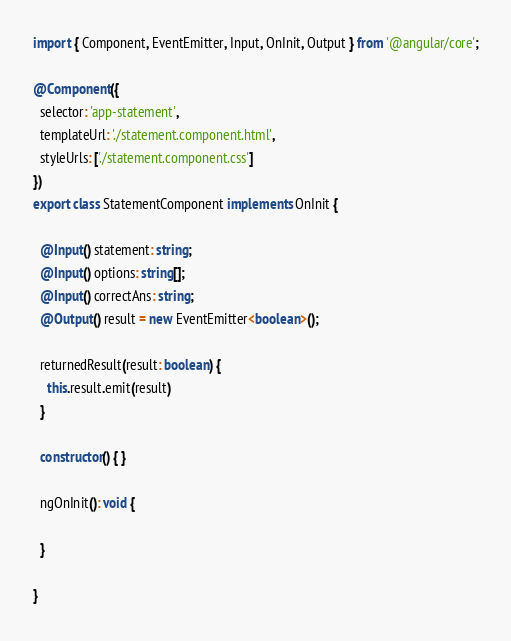Convert code to text. <code><loc_0><loc_0><loc_500><loc_500><_TypeScript_>import { Component, EventEmitter, Input, OnInit, Output } from '@angular/core';

@Component({
  selector: 'app-statement',
  templateUrl: './statement.component.html',
  styleUrls: ['./statement.component.css']
})
export class StatementComponent implements OnInit {

  @Input() statement: string;
  @Input() options: string[];
  @Input() correctAns: string;
  @Output() result = new EventEmitter<boolean>();

  returnedResult(result: boolean) {
    this.result.emit(result)
  }
  
  constructor() { }

  ngOnInit(): void {

  }

}
</code> 